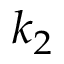Convert formula to latex. <formula><loc_0><loc_0><loc_500><loc_500>k _ { 2 }</formula> 